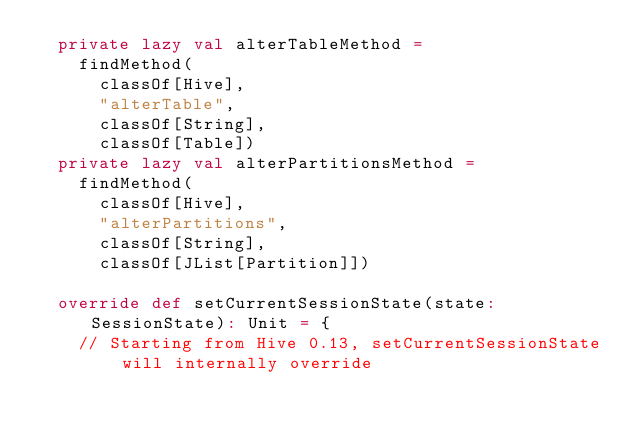Convert code to text. <code><loc_0><loc_0><loc_500><loc_500><_Scala_>  private lazy val alterTableMethod =
    findMethod(
      classOf[Hive],
      "alterTable",
      classOf[String],
      classOf[Table])
  private lazy val alterPartitionsMethod =
    findMethod(
      classOf[Hive],
      "alterPartitions",
      classOf[String],
      classOf[JList[Partition]])

  override def setCurrentSessionState(state: SessionState): Unit = {
    // Starting from Hive 0.13, setCurrentSessionState will internally override</code> 